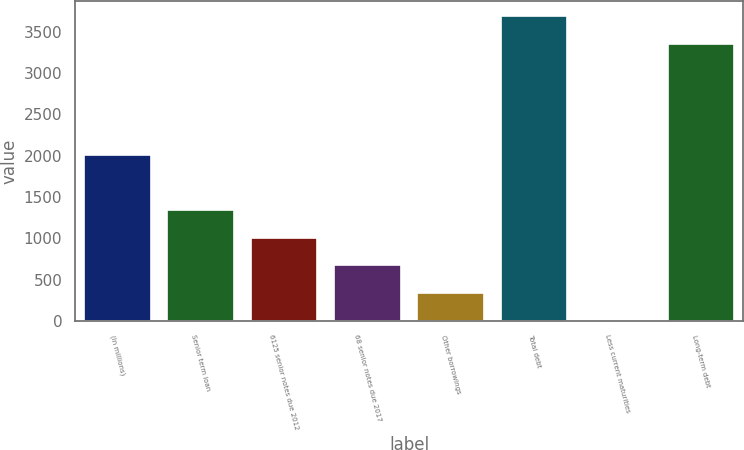Convert chart to OTSL. <chart><loc_0><loc_0><loc_500><loc_500><bar_chart><fcel>(In millions)<fcel>Senior term loan<fcel>6125 senior notes due 2012<fcel>68 senior notes due 2017<fcel>Other borrowings<fcel>Total debt<fcel>Less current maturities<fcel>Long-term debt<nl><fcel>2010<fcel>1344.2<fcel>1008.9<fcel>673.6<fcel>338.3<fcel>3688.3<fcel>3<fcel>3353<nl></chart> 